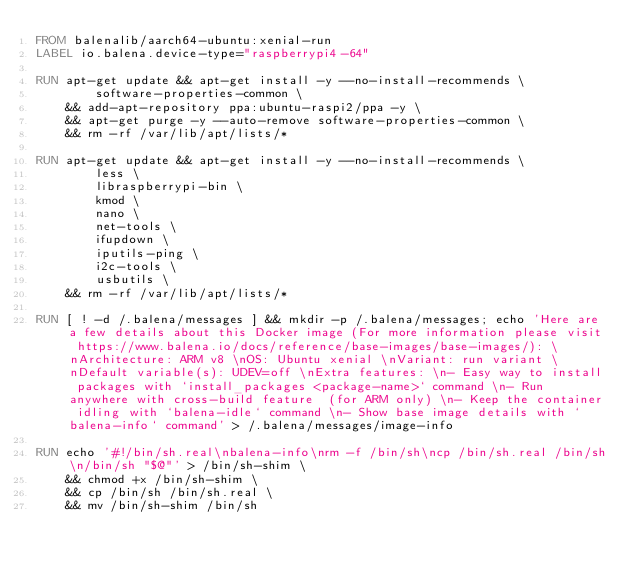<code> <loc_0><loc_0><loc_500><loc_500><_Dockerfile_>FROM balenalib/aarch64-ubuntu:xenial-run
LABEL io.balena.device-type="raspberrypi4-64"

RUN apt-get update && apt-get install -y --no-install-recommends \
		software-properties-common \
	&& add-apt-repository ppa:ubuntu-raspi2/ppa -y \
	&& apt-get purge -y --auto-remove software-properties-common \
	&& rm -rf /var/lib/apt/lists/*

RUN apt-get update && apt-get install -y --no-install-recommends \
		less \
		libraspberrypi-bin \
		kmod \
		nano \
		net-tools \
		ifupdown \
		iputils-ping \
		i2c-tools \
		usbutils \
	&& rm -rf /var/lib/apt/lists/*

RUN [ ! -d /.balena/messages ] && mkdir -p /.balena/messages; echo 'Here are a few details about this Docker image (For more information please visit https://www.balena.io/docs/reference/base-images/base-images/): \nArchitecture: ARM v8 \nOS: Ubuntu xenial \nVariant: run variant \nDefault variable(s): UDEV=off \nExtra features: \n- Easy way to install packages with `install_packages <package-name>` command \n- Run anywhere with cross-build feature  (for ARM only) \n- Keep the container idling with `balena-idle` command \n- Show base image details with `balena-info` command' > /.balena/messages/image-info

RUN echo '#!/bin/sh.real\nbalena-info\nrm -f /bin/sh\ncp /bin/sh.real /bin/sh\n/bin/sh "$@"' > /bin/sh-shim \
	&& chmod +x /bin/sh-shim \
	&& cp /bin/sh /bin/sh.real \
	&& mv /bin/sh-shim /bin/sh</code> 